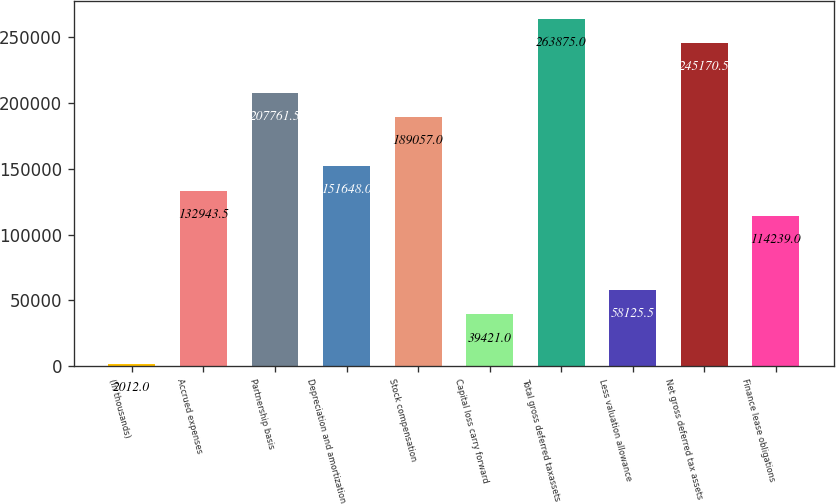<chart> <loc_0><loc_0><loc_500><loc_500><bar_chart><fcel>(In thousands)<fcel>Accrued expenses<fcel>Partnership basis<fcel>Depreciation and amortization<fcel>Stock compensation<fcel>Capital loss carry forward<fcel>Total gross deferred taxassets<fcel>Less valuation allowance<fcel>Net gross deferred tax assets<fcel>Finance lease obligations<nl><fcel>2012<fcel>132944<fcel>207762<fcel>151648<fcel>189057<fcel>39421<fcel>263875<fcel>58125.5<fcel>245170<fcel>114239<nl></chart> 